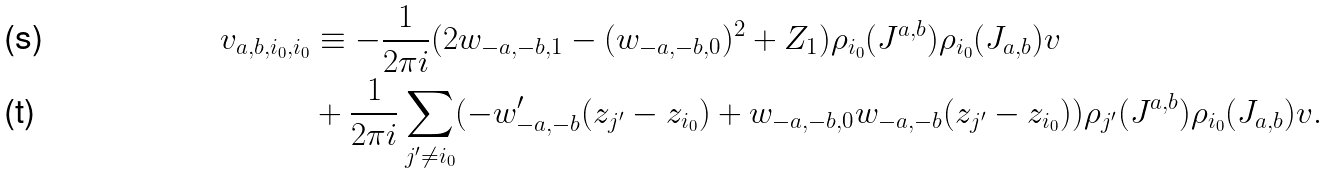Convert formula to latex. <formula><loc_0><loc_0><loc_500><loc_500>v _ { a , b , i _ { 0 } , i _ { 0 } } & \equiv - \frac { 1 } { 2 \pi i } ( 2 w _ { - a , - b , 1 } - ( w _ { - a , - b , 0 } ) ^ { 2 } + Z _ { 1 } ) \rho _ { i _ { 0 } } ( J ^ { a , b } ) \rho _ { i _ { 0 } } ( J _ { a , b } ) v \\ & + \frac { 1 } { 2 \pi i } \sum _ { j ^ { \prime } \ne i _ { 0 } } ( - w ^ { \prime } _ { - a , - b } ( z _ { j ^ { \prime } } - z _ { i _ { 0 } } ) + w _ { - a , - b , 0 } w _ { - a , - b } ( z _ { j ^ { \prime } } - z _ { i _ { 0 } } ) ) \rho _ { j ^ { \prime } } ( J ^ { a , b } ) \rho _ { i _ { 0 } } ( J _ { a , b } ) v .</formula> 